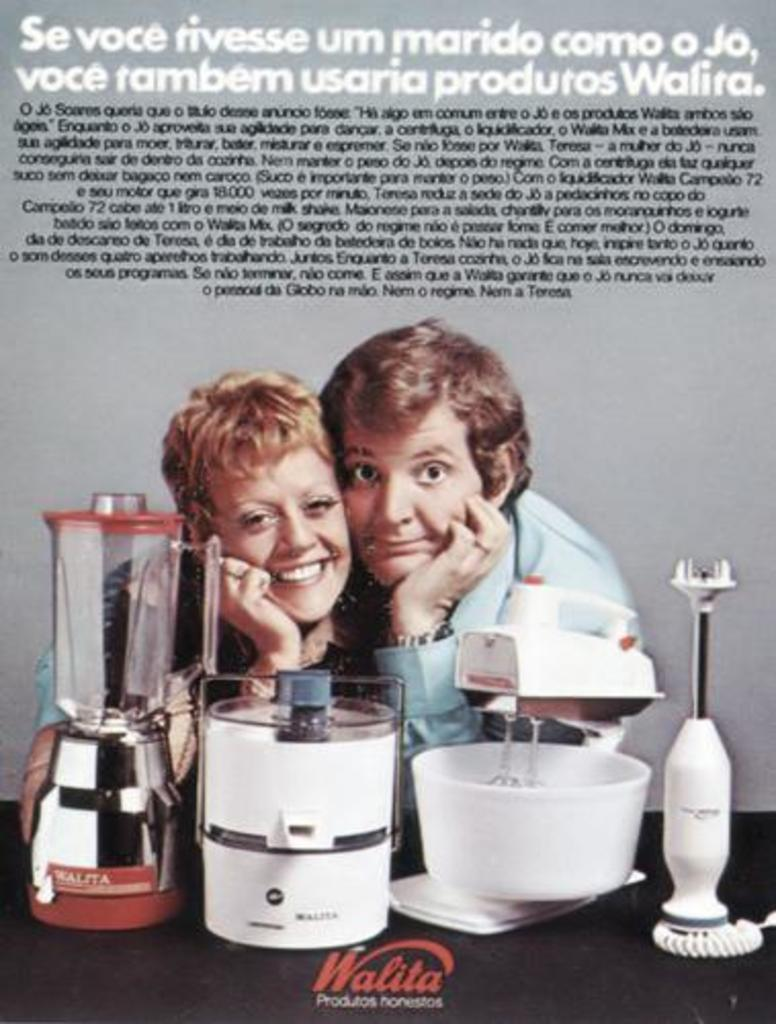<image>
Offer a succinct explanation of the picture presented. the word walita is under the two people posing 